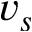Convert formula to latex. <formula><loc_0><loc_0><loc_500><loc_500>v _ { s }</formula> 